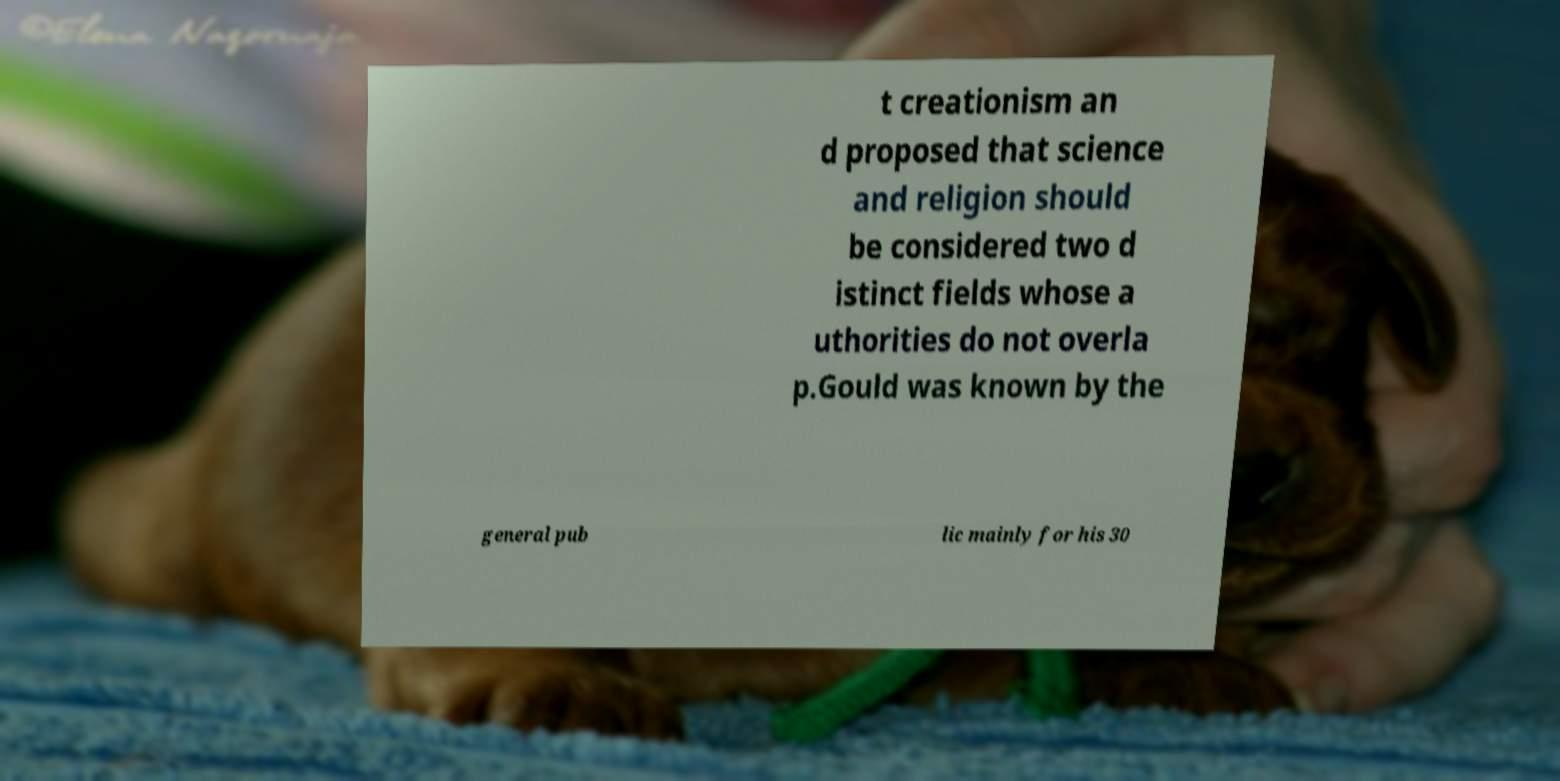What messages or text are displayed in this image? I need them in a readable, typed format. t creationism an d proposed that science and religion should be considered two d istinct fields whose a uthorities do not overla p.Gould was known by the general pub lic mainly for his 30 